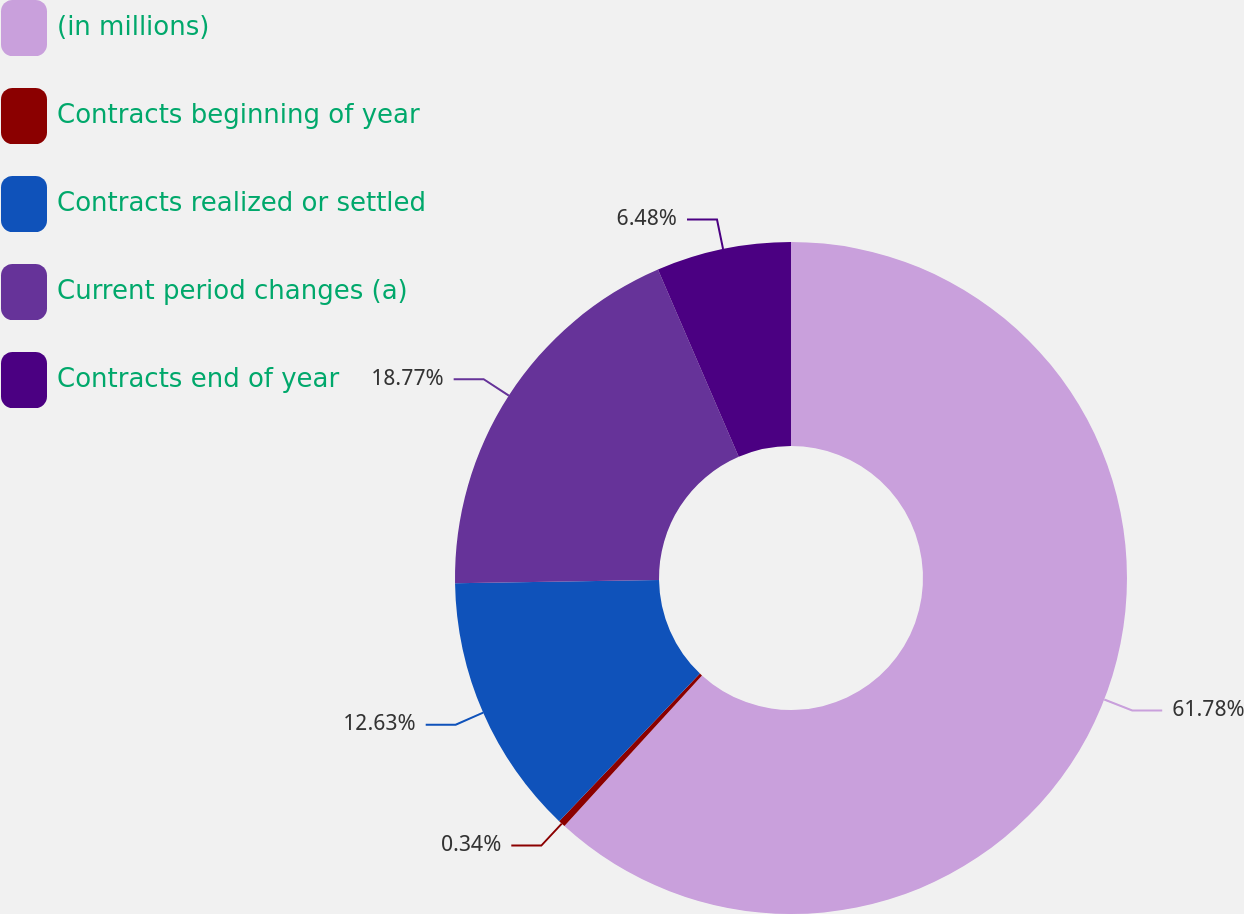<chart> <loc_0><loc_0><loc_500><loc_500><pie_chart><fcel>(in millions)<fcel>Contracts beginning of year<fcel>Contracts realized or settled<fcel>Current period changes (a)<fcel>Contracts end of year<nl><fcel>61.78%<fcel>0.34%<fcel>12.63%<fcel>18.77%<fcel>6.48%<nl></chart> 